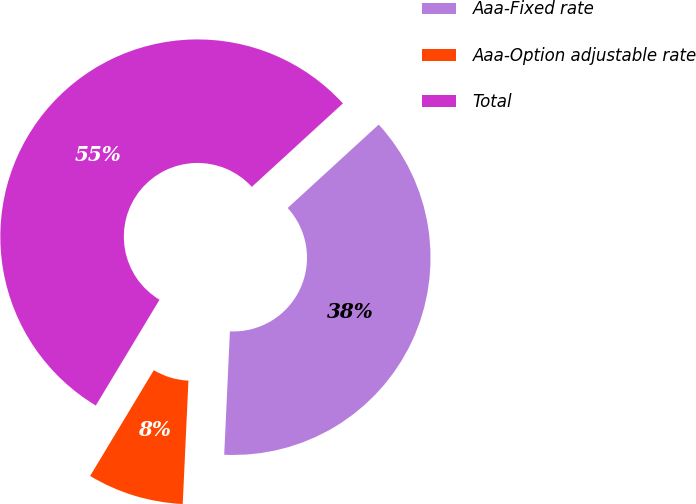Convert chart to OTSL. <chart><loc_0><loc_0><loc_500><loc_500><pie_chart><fcel>Aaa-Fixed rate<fcel>Aaa-Option adjustable rate<fcel>Total<nl><fcel>37.54%<fcel>7.89%<fcel>54.57%<nl></chart> 